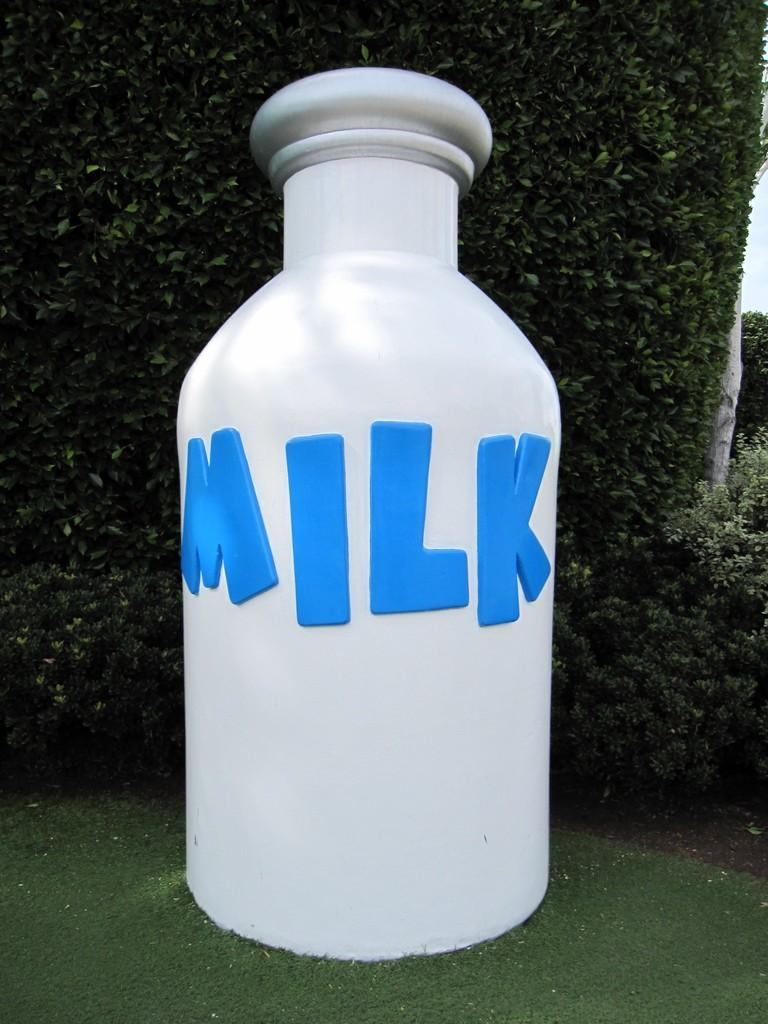Provide a one-sentence caption for the provided image. An extremely large bottle of milk is sat on the lawn. 